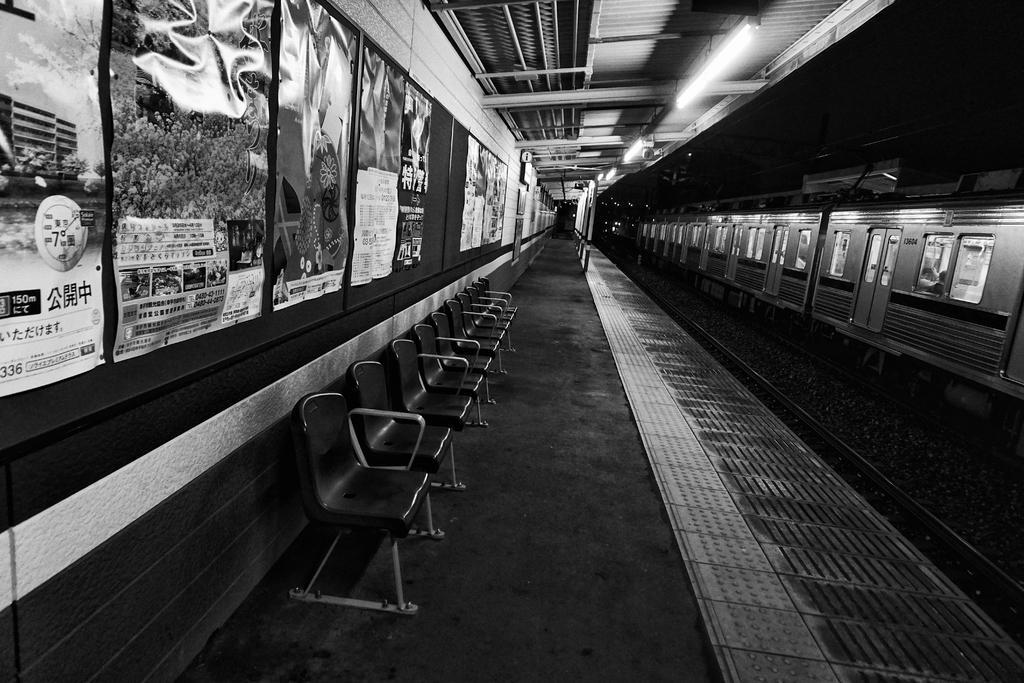In one or two sentences, can you explain what this image depicts? In the image I can see a railway station in which there is a train on the train and also I can see some chairs and banners to the wall. 